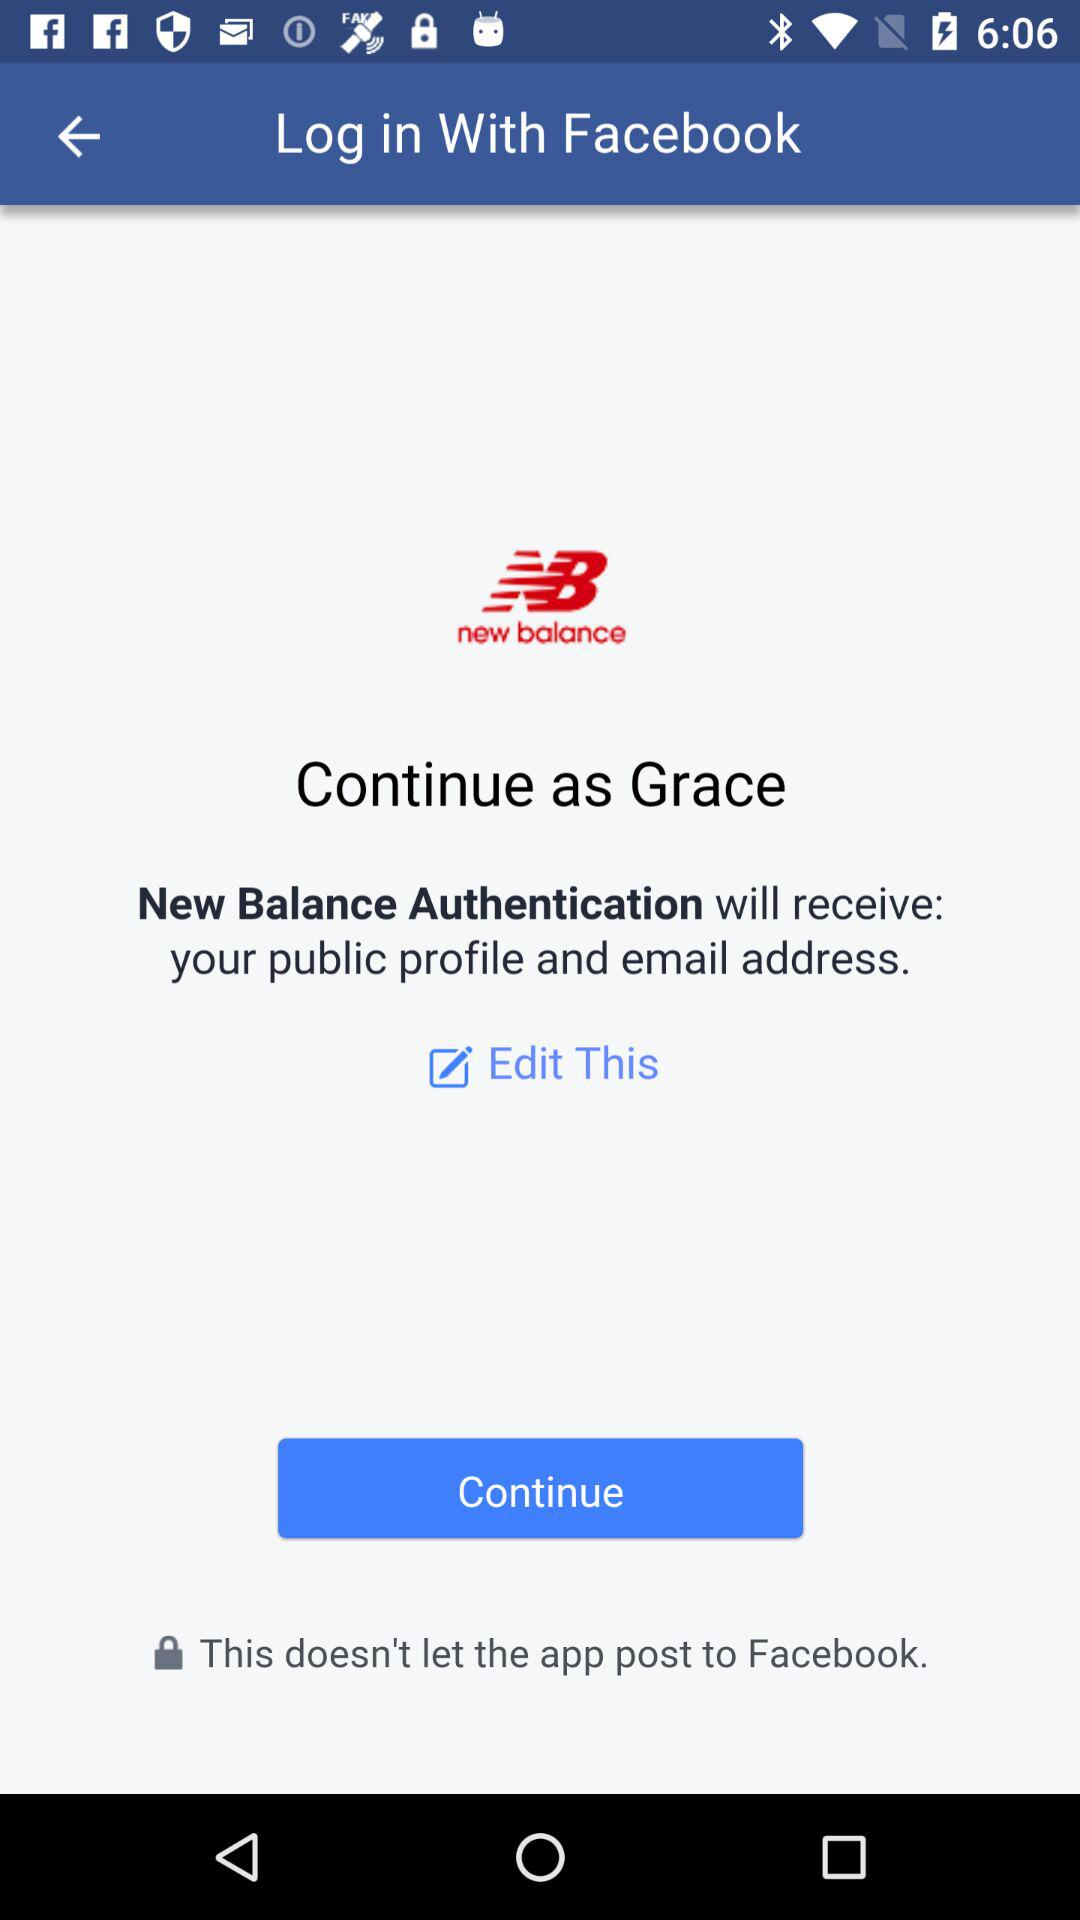What account am I using to log in? You are using the "Facebook" account to log in. 